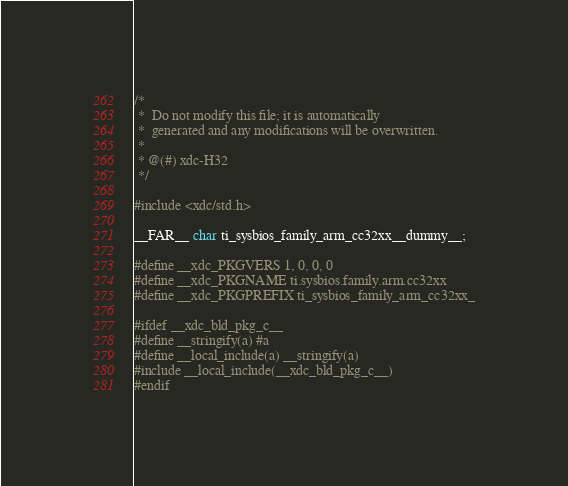<code> <loc_0><loc_0><loc_500><loc_500><_C_>/*
 *  Do not modify this file; it is automatically 
 *  generated and any modifications will be overwritten.
 *
 * @(#) xdc-H32
 */

#include <xdc/std.h>

__FAR__ char ti_sysbios_family_arm_cc32xx__dummy__;

#define __xdc_PKGVERS 1, 0, 0, 0
#define __xdc_PKGNAME ti.sysbios.family.arm.cc32xx
#define __xdc_PKGPREFIX ti_sysbios_family_arm_cc32xx_

#ifdef __xdc_bld_pkg_c__
#define __stringify(a) #a
#define __local_include(a) __stringify(a)
#include __local_include(__xdc_bld_pkg_c__)
#endif

</code> 